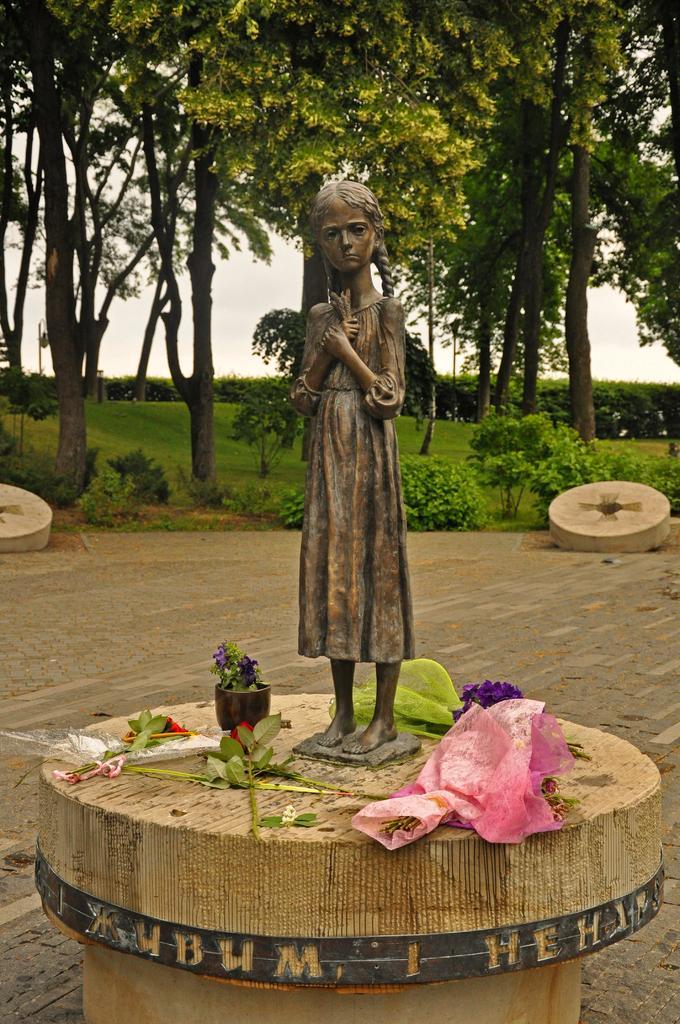Describe this image in one or two sentences. In the middle of the image we can see a statue and there are some leaves, plants and flowers. Behind the statue we can see some plants and trees. Behind the trees there is sky. 